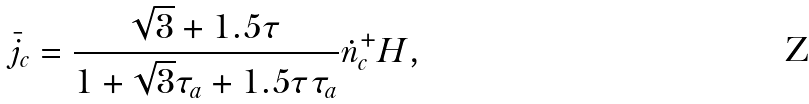<formula> <loc_0><loc_0><loc_500><loc_500>\bar { j } _ { c } = \frac { \sqrt { 3 } + 1 . 5 \tau } { 1 + \sqrt { 3 } \tau _ { a } + 1 . 5 \tau \tau _ { a } } \dot { n } _ { c } ^ { + } H ,</formula> 